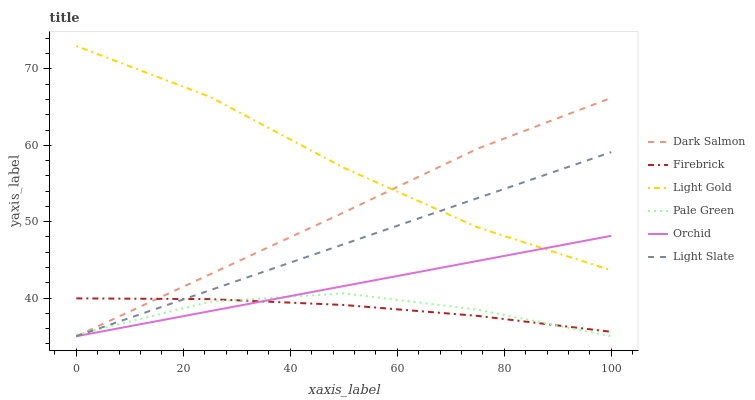Does Pale Green have the minimum area under the curve?
Answer yes or no. Yes. Does Light Gold have the maximum area under the curve?
Answer yes or no. Yes. Does Firebrick have the minimum area under the curve?
Answer yes or no. No. Does Firebrick have the maximum area under the curve?
Answer yes or no. No. Is Orchid the smoothest?
Answer yes or no. Yes. Is Pale Green the roughest?
Answer yes or no. Yes. Is Firebrick the smoothest?
Answer yes or no. No. Is Firebrick the roughest?
Answer yes or no. No. Does Firebrick have the lowest value?
Answer yes or no. No. Does Light Gold have the highest value?
Answer yes or no. Yes. Does Dark Salmon have the highest value?
Answer yes or no. No. Is Firebrick less than Light Gold?
Answer yes or no. Yes. Is Light Gold greater than Firebrick?
Answer yes or no. Yes. Does Firebrick intersect Light Gold?
Answer yes or no. No. 